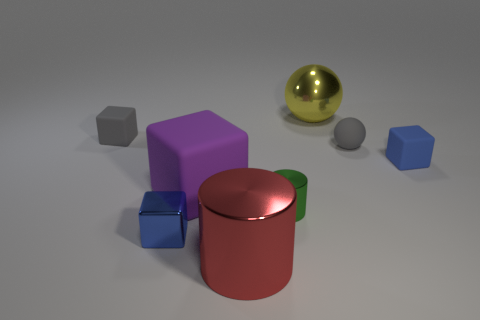What number of small gray things are in front of the gray thing to the left of the blue metal block? 1 